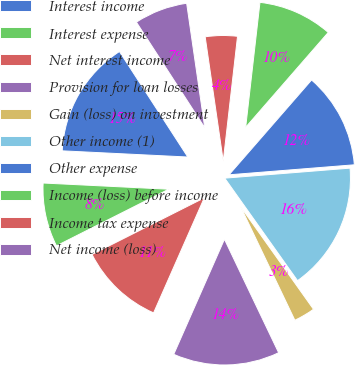Convert chart to OTSL. <chart><loc_0><loc_0><loc_500><loc_500><pie_chart><fcel>Interest income<fcel>Interest expense<fcel>Net interest income<fcel>Provision for loan losses<fcel>Gain (loss) on investment<fcel>Other income (1)<fcel>Other expense<fcel>Income (loss) before income<fcel>Income tax expense<fcel>Net income (loss)<nl><fcel>15.07%<fcel>8.22%<fcel>10.96%<fcel>13.7%<fcel>2.74%<fcel>16.44%<fcel>12.33%<fcel>9.59%<fcel>4.11%<fcel>6.85%<nl></chart> 